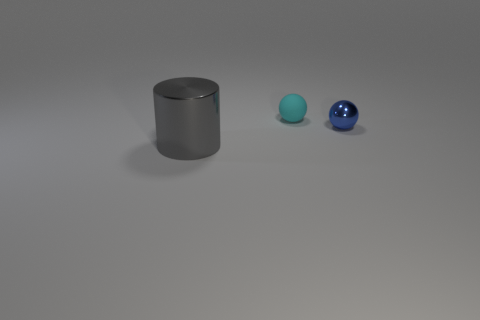What can you infer about the lighting and shadows in the image? The lighting in this image suggests a single diffuse light source coming from the upper right corner, given the shadows cast to the left of each object. All objects have soft-edged shadows, indicating the light source is not harsh, such as one you might expect from an overcast sky or a softbox in a photography studio. 